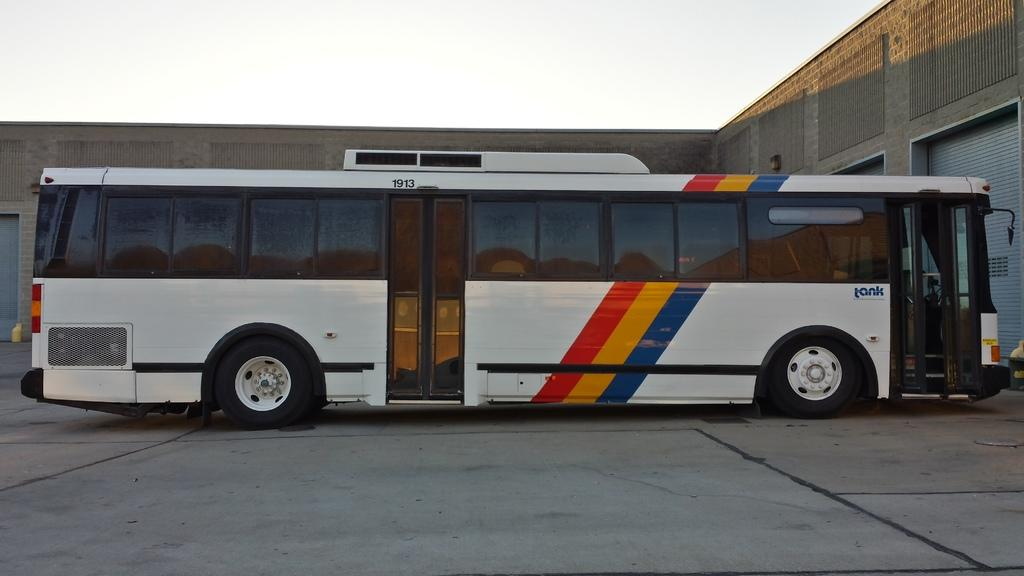What is the main subject of the image? The main subject of the image is a bus. Can you describe the setting of the image? In the background of the image, there is a building. What type of drug is being sold by the bus driver in the image? There is no indication of drug sales or a bus driver in the image; it simply features a bus and a building in the background. 